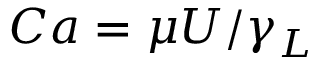<formula> <loc_0><loc_0><loc_500><loc_500>C a = \mu U / \gamma _ { L }</formula> 